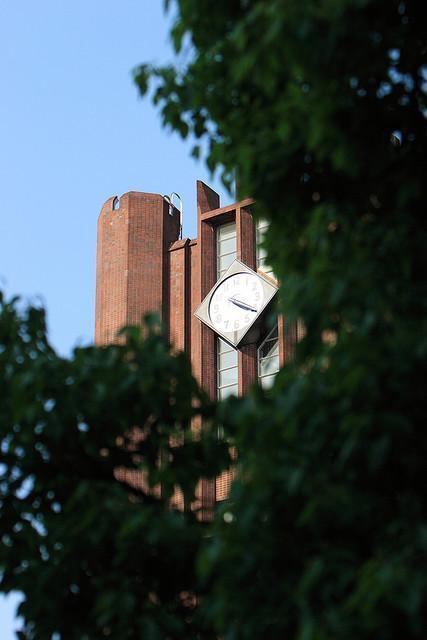How many clocks are in the photo?
Give a very brief answer. 1. How many giraffes are in the picture?
Give a very brief answer. 0. 